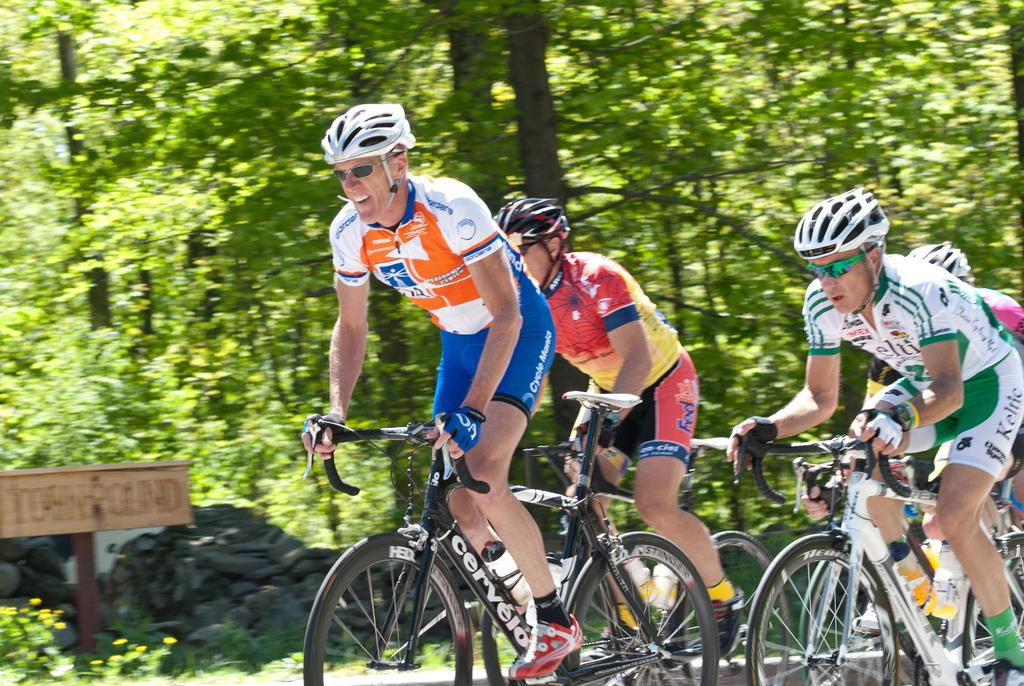Who or what can be seen in the image? There are people in the image. What are the people wearing on their heads? The people are wearing helmets. What activity are the people engaged in? The people are riding bicycles. What can be seen in the background of the image? There is a board and trees in the background of the image. How does the doll compare to the people in the image? There is no doll present in the image, so it cannot be compared to the people. 